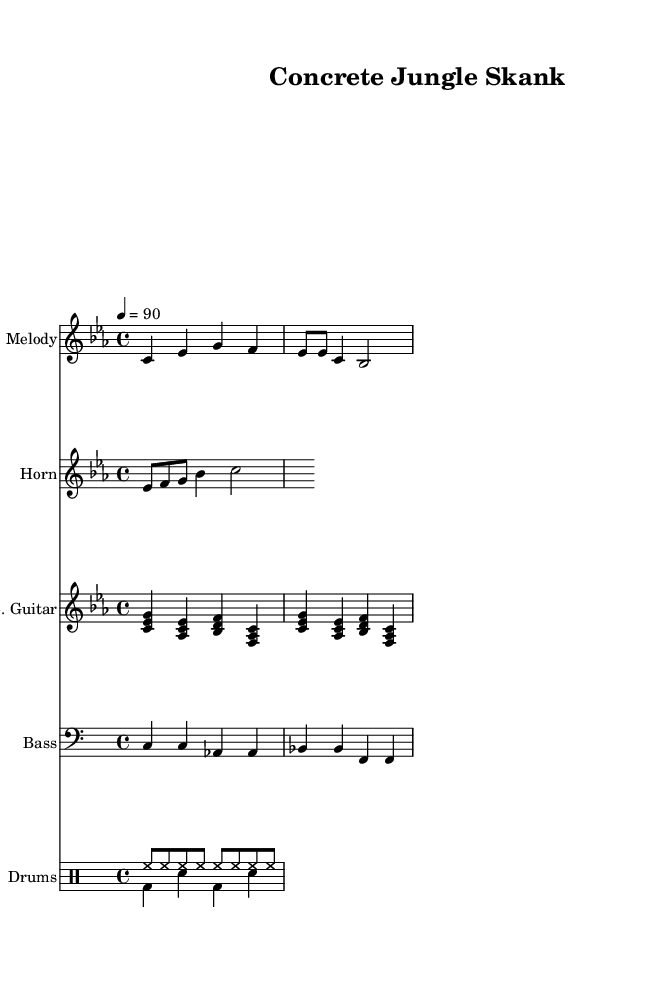What is the key signature of this music? The key signature is C minor, indicated by three flat notes in the key signature (B, E, and A).
Answer: C minor What is the time signature of this music? The time signature is 4/4, which shows that there are four beats in a measure, and the quarter note gets one beat, as indicated at the beginning of the score.
Answer: 4/4 What is the tempo marking of the piece? The tempo marking indicates a speed of 90 beats per minute, stated at the beginning of the score.
Answer: 90 How many measures does the melody contain? The melody consists of three measures, as indicated by the grouping of notes across the staff.
Answer: 3 What type of rhythm features prominently in the drum patterns? The drum patterns feature a combination of a steady hi-hat pattern and a backbeat from the snare drum on the second and fourth beats, characteristic of reggae music.
Answer: Steady hi-hat, backbeat What instrument plays the melody? The melody is played on the instrument labeled "Melody" which is typically a lead instrument like a keyboard or a solo instrument in a reggae context.
Answer: Melody Is the bass line prominent in the overall arrangement? The bass line is an essential component of reggae music, providing a rhythmic and harmonic foundation, as indicated by its own dedicated staff in the score.
Answer: Yes 